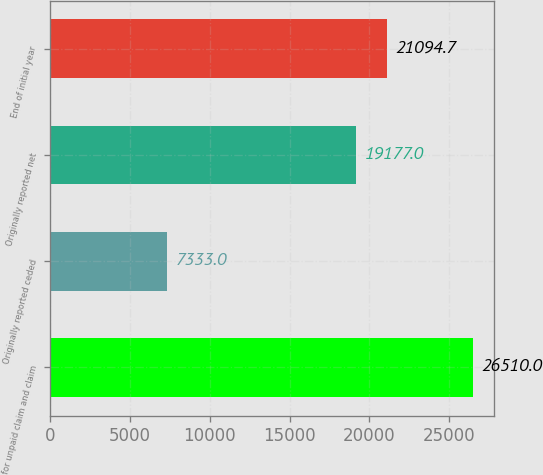<chart> <loc_0><loc_0><loc_500><loc_500><bar_chart><fcel>for unpaid claim and claim<fcel>Originally reported ceded<fcel>Originally reported net<fcel>End of initial year<nl><fcel>26510<fcel>7333<fcel>19177<fcel>21094.7<nl></chart> 